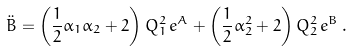<formula> <loc_0><loc_0><loc_500><loc_500>\ddot { B } = \left ( \frac { 1 } { 2 } \alpha _ { 1 } \alpha _ { 2 } + 2 \right ) Q _ { 1 } ^ { 2 } \, e ^ { A } + \left ( \frac { 1 } { 2 } \alpha _ { 2 } ^ { 2 } + 2 \right ) Q _ { 2 } ^ { 2 } \, e ^ { B } \, .</formula> 